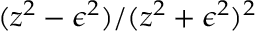Convert formula to latex. <formula><loc_0><loc_0><loc_500><loc_500>{ ( z ^ { 2 } - \epsilon ^ { 2 } ) } / { ( z ^ { 2 } + \epsilon ^ { 2 } ) ^ { 2 } }</formula> 